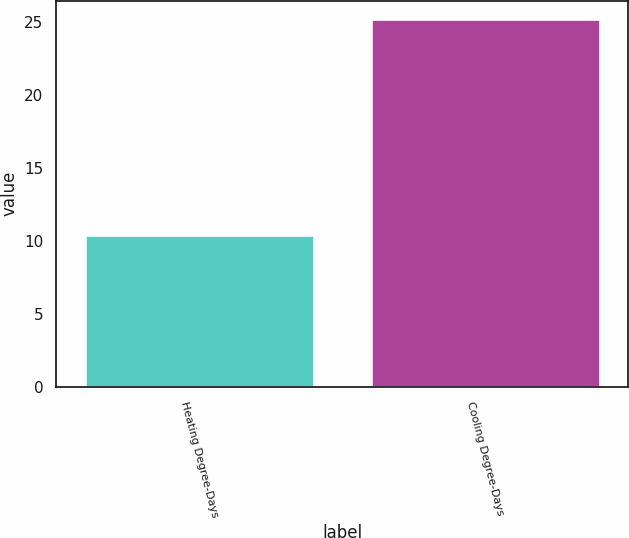<chart> <loc_0><loc_0><loc_500><loc_500><bar_chart><fcel>Heating Degree-Days<fcel>Cooling Degree-Days<nl><fcel>10.4<fcel>25.2<nl></chart> 